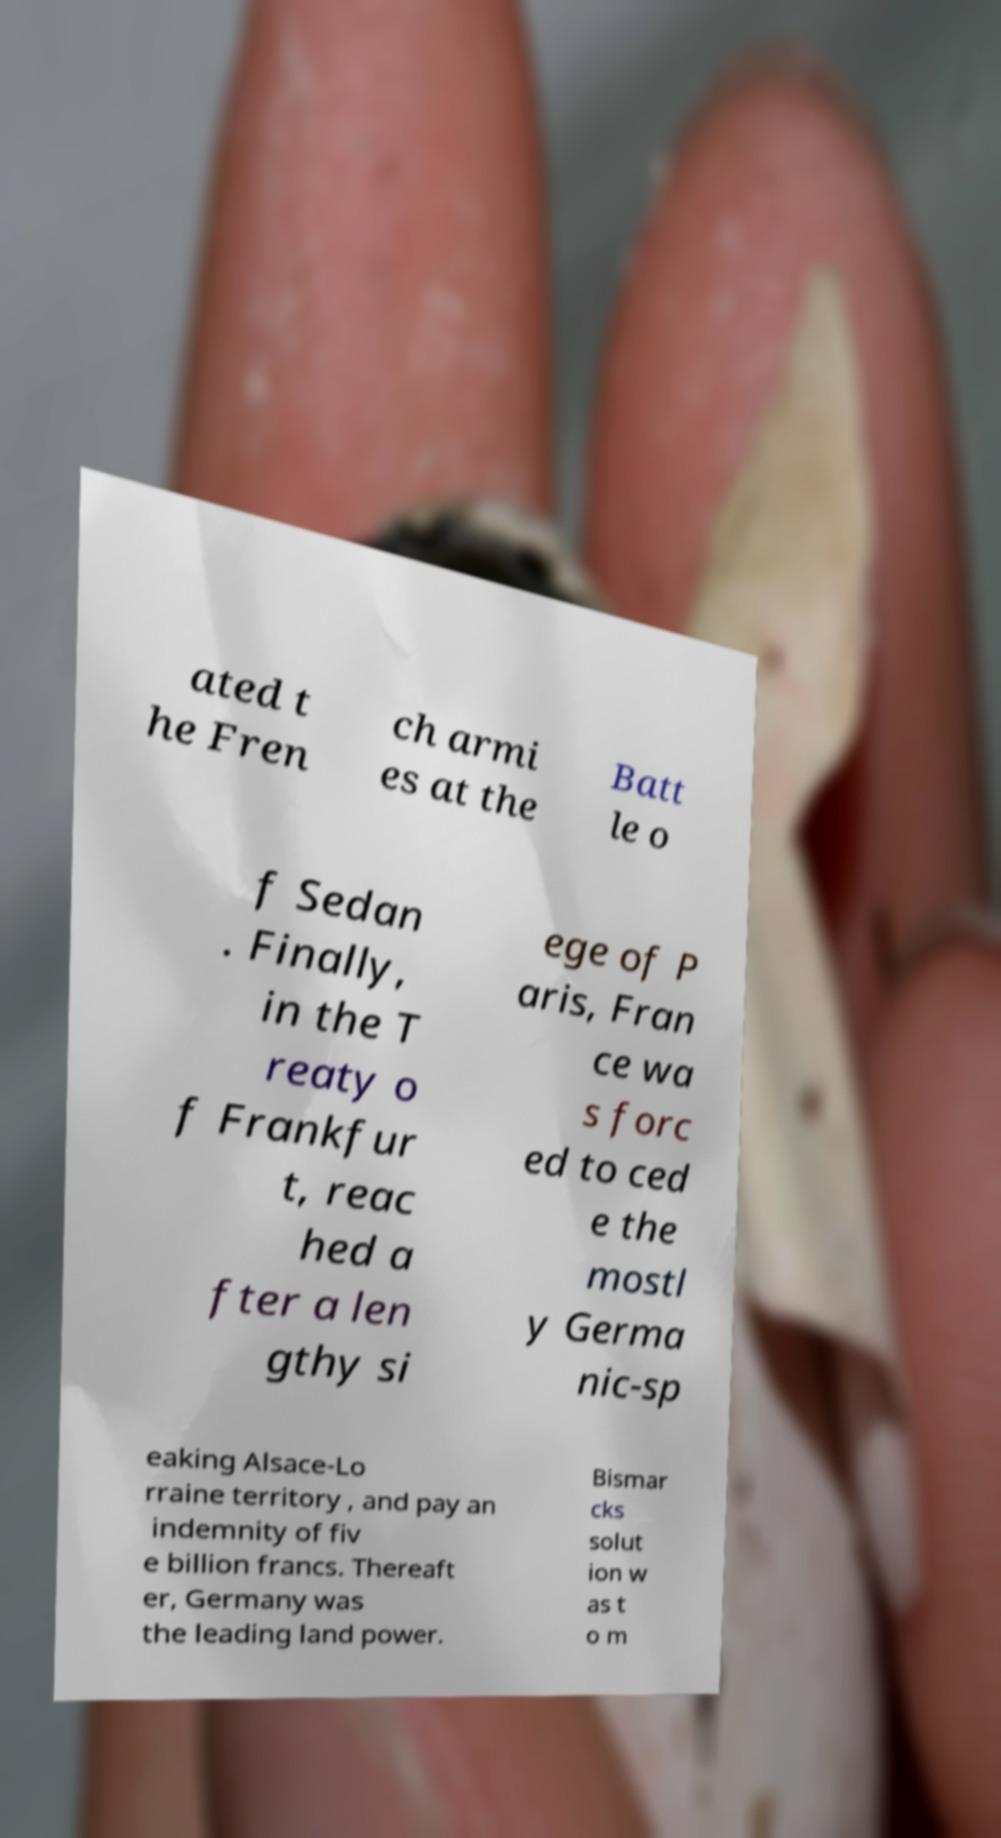Could you extract and type out the text from this image? ated t he Fren ch armi es at the Batt le o f Sedan . Finally, in the T reaty o f Frankfur t, reac hed a fter a len gthy si ege of P aris, Fran ce wa s forc ed to ced e the mostl y Germa nic-sp eaking Alsace-Lo rraine territory , and pay an indemnity of fiv e billion francs. Thereaft er, Germany was the leading land power. Bismar cks solut ion w as t o m 